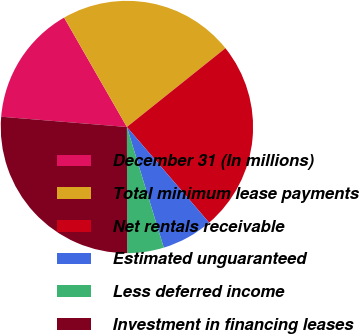<chart> <loc_0><loc_0><loc_500><loc_500><pie_chart><fcel>December 31 (In millions)<fcel>Total minimum lease payments<fcel>Net rentals receivable<fcel>Estimated unguaranteed<fcel>Less deferred income<fcel>Investment in financing leases<nl><fcel>15.41%<fcel>22.56%<fcel>24.44%<fcel>6.58%<fcel>4.69%<fcel>26.33%<nl></chart> 